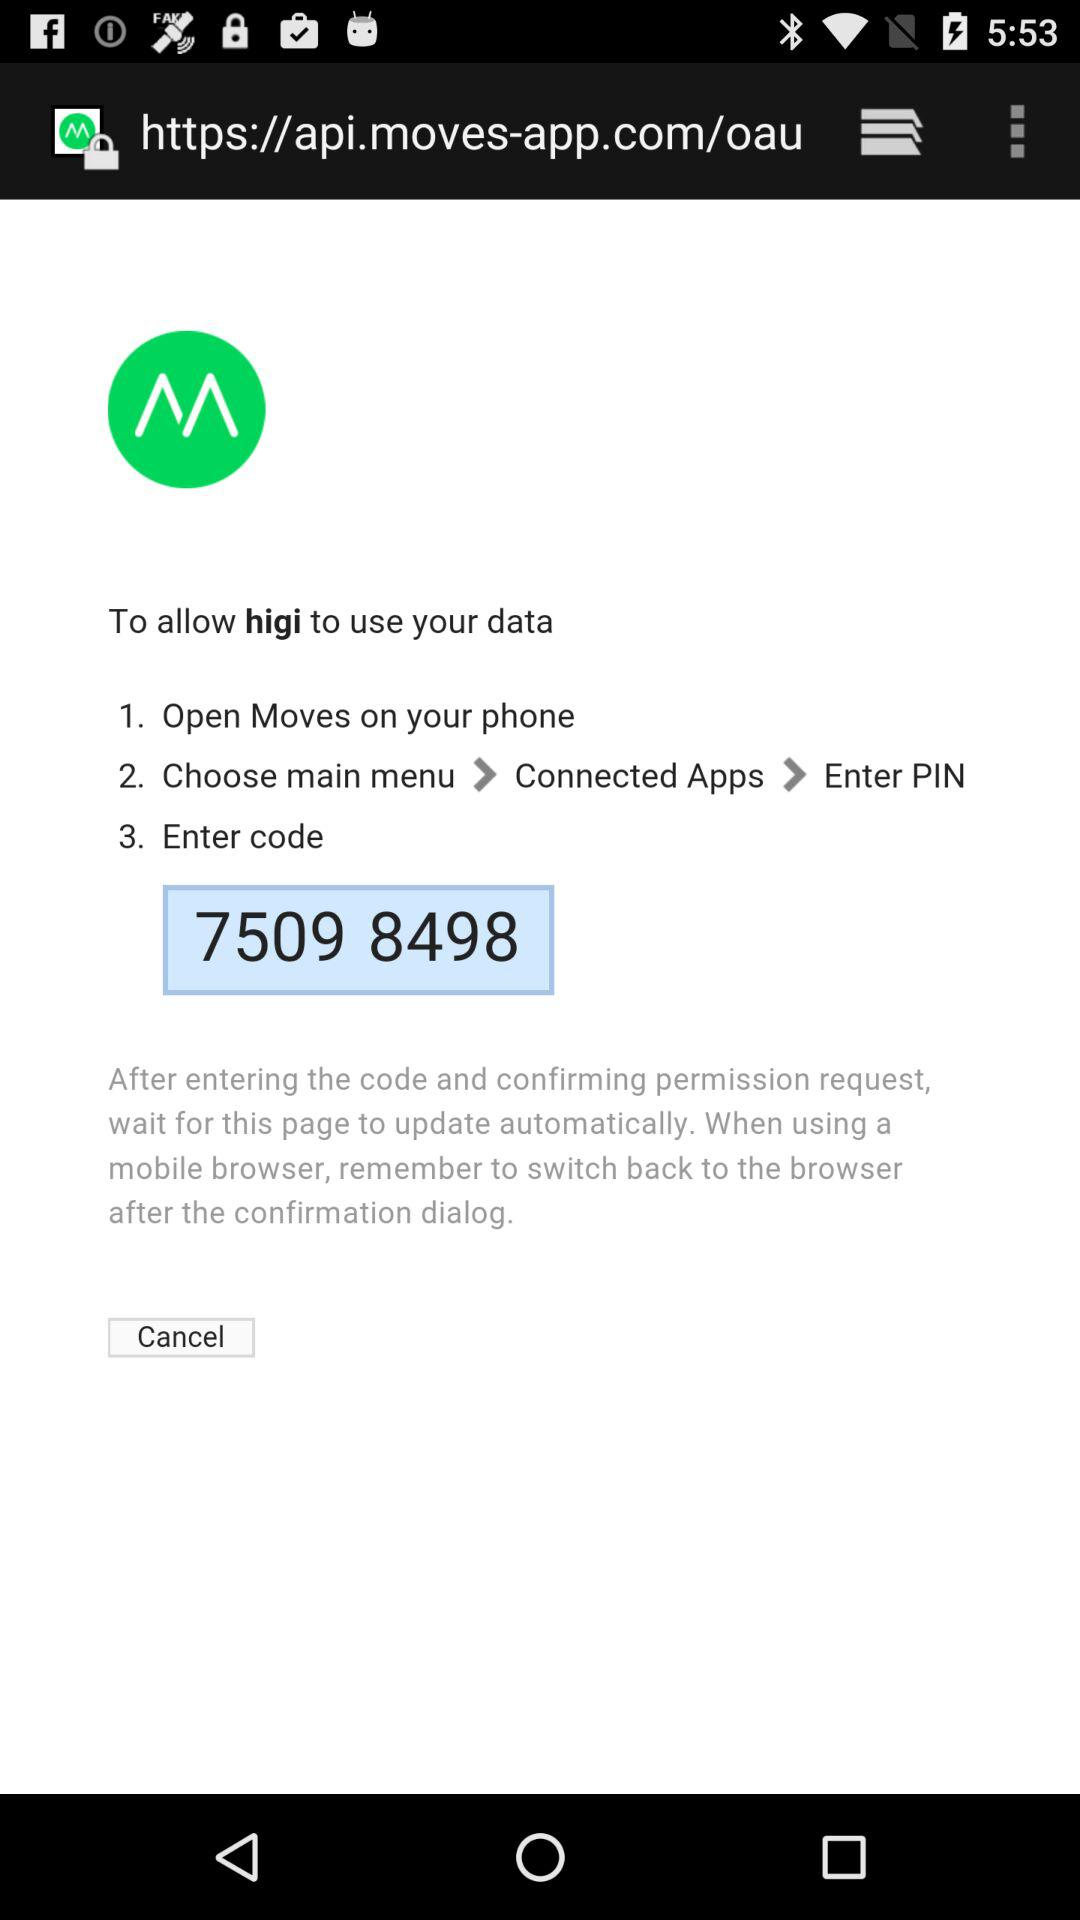What is the code? The code is 7509 8498. 